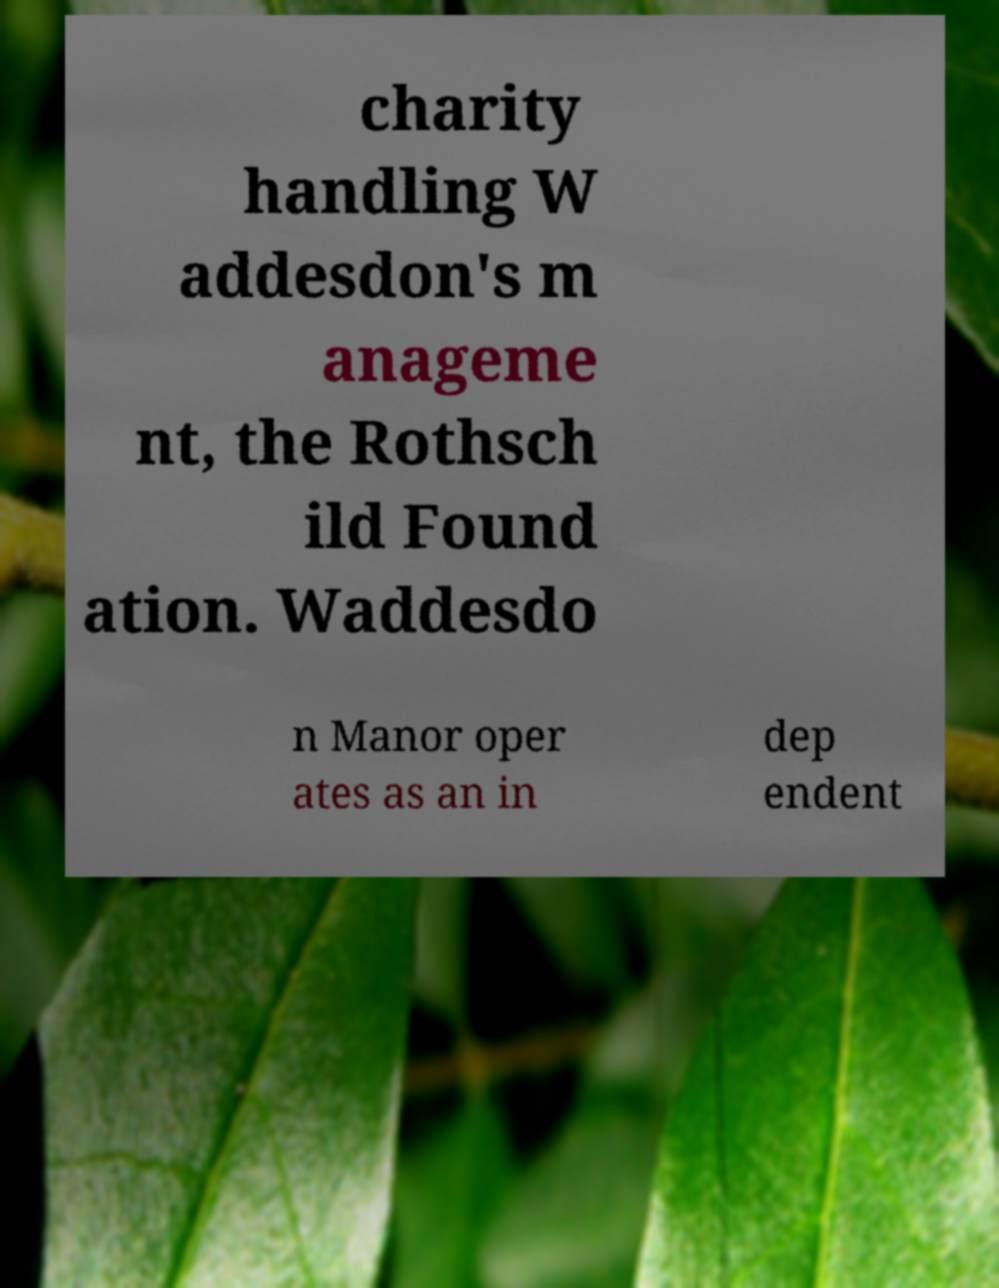Please identify and transcribe the text found in this image. charity handling W addesdon's m anageme nt, the Rothsch ild Found ation. Waddesdo n Manor oper ates as an in dep endent 